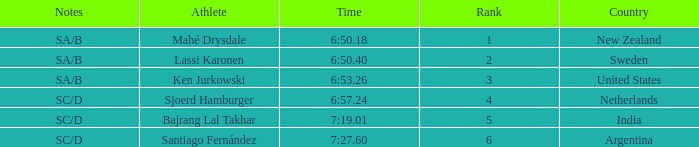What is the highest rank for the team that raced a time of 6:50.40? 2.0. 